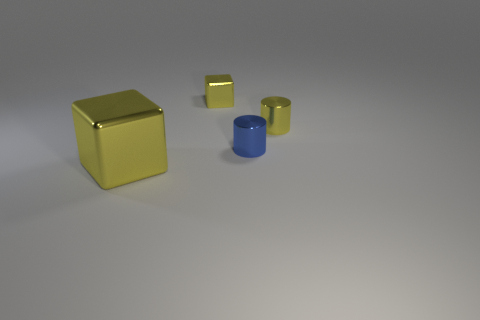There is a big thing that is the same material as the small blue thing; what is its color?
Your answer should be very brief. Yellow. What material is the small yellow object that is the same shape as the small blue thing?
Your response must be concise. Metal. What is the shape of the large thing?
Provide a short and direct response. Cube. There is a yellow thing that is on the left side of the yellow shiny cylinder and behind the large yellow thing; what is it made of?
Give a very brief answer. Metal. What shape is the blue thing that is the same material as the large yellow object?
Your answer should be very brief. Cylinder. There is a yellow cylinder that is made of the same material as the blue thing; what size is it?
Provide a short and direct response. Small. There is a yellow object that is to the left of the blue thing and in front of the tiny cube; what shape is it?
Your answer should be compact. Cube. What size is the yellow thing that is on the left side of the block right of the large thing?
Offer a terse response. Large. What number of other things are there of the same color as the big metallic object?
Your answer should be compact. 2. What is the tiny blue thing made of?
Your answer should be compact. Metal. 